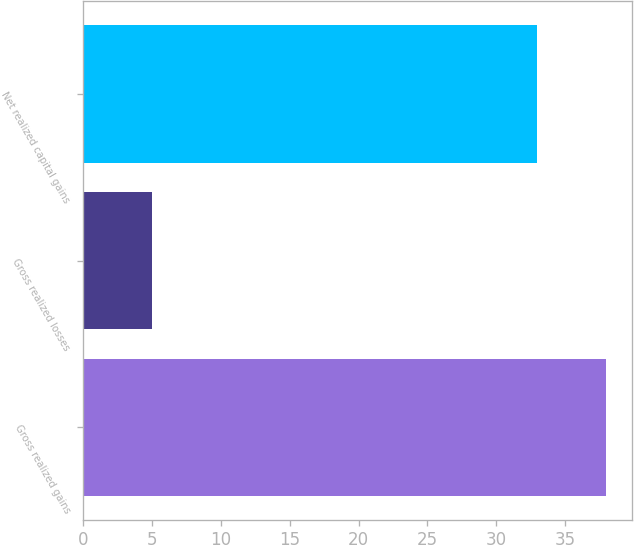Convert chart to OTSL. <chart><loc_0><loc_0><loc_500><loc_500><bar_chart><fcel>Gross realized gains<fcel>Gross realized losses<fcel>Net realized capital gains<nl><fcel>38<fcel>5<fcel>33<nl></chart> 